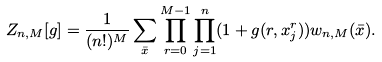Convert formula to latex. <formula><loc_0><loc_0><loc_500><loc_500>Z _ { n , M } [ g ] = \frac { 1 } { ( n ! ) ^ { M } } \sum _ { \bar { x } } \prod _ { r = 0 } ^ { M - 1 } \prod _ { j = 1 } ^ { n } ( 1 + g ( r , x _ { j } ^ { r } ) ) w _ { n , M } ( \bar { x } ) .</formula> 